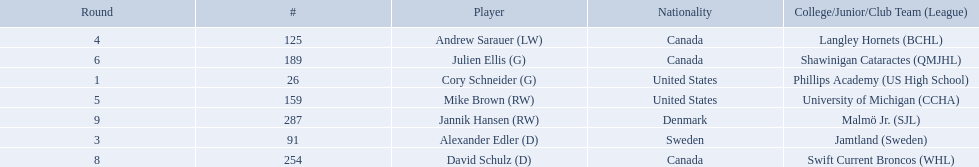Who were the players in the 2004-05 vancouver canucks season Cory Schneider (G), Alexander Edler (D), Andrew Sarauer (LW), Mike Brown (RW), Julien Ellis (G), David Schulz (D), Jannik Hansen (RW). Of these players who had a nationality of denmark? Jannik Hansen (RW). 